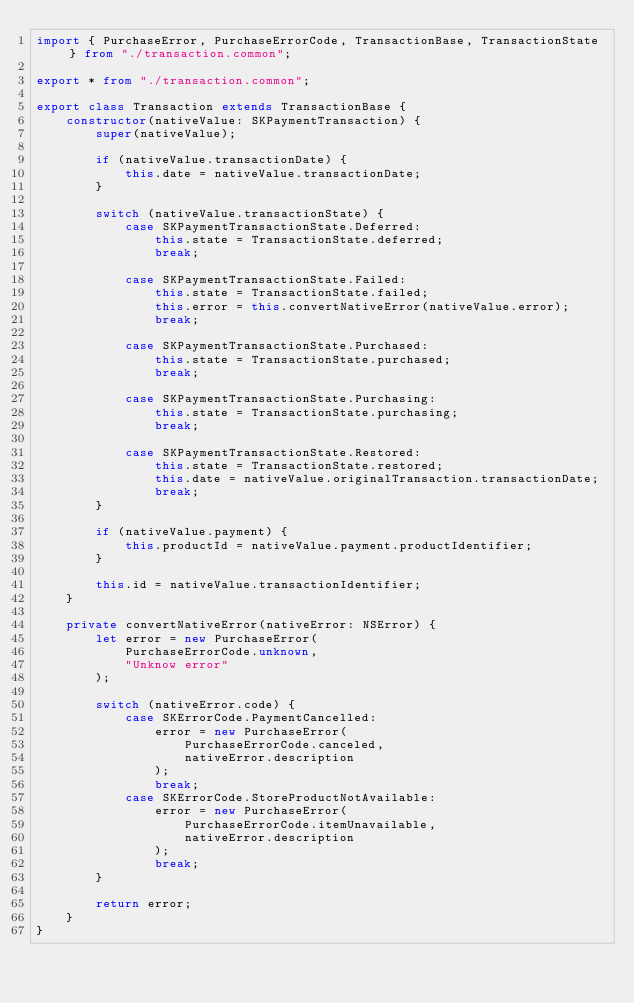<code> <loc_0><loc_0><loc_500><loc_500><_TypeScript_>import { PurchaseError, PurchaseErrorCode, TransactionBase, TransactionState } from "./transaction.common";

export * from "./transaction.common";

export class Transaction extends TransactionBase {
    constructor(nativeValue: SKPaymentTransaction) {
        super(nativeValue);

        if (nativeValue.transactionDate) {
            this.date = nativeValue.transactionDate;
        }

        switch (nativeValue.transactionState) {
            case SKPaymentTransactionState.Deferred:
                this.state = TransactionState.deferred;
                break;

            case SKPaymentTransactionState.Failed:
                this.state = TransactionState.failed;
                this.error = this.convertNativeError(nativeValue.error);
                break;

            case SKPaymentTransactionState.Purchased:
                this.state = TransactionState.purchased;
                break;

            case SKPaymentTransactionState.Purchasing:
                this.state = TransactionState.purchasing;
                break;

            case SKPaymentTransactionState.Restored:
                this.state = TransactionState.restored;
                this.date = nativeValue.originalTransaction.transactionDate;
                break;
        }

        if (nativeValue.payment) {
            this.productId = nativeValue.payment.productIdentifier;
        }

        this.id = nativeValue.transactionIdentifier;
    }

    private convertNativeError(nativeError: NSError) {
        let error = new PurchaseError(
            PurchaseErrorCode.unknown,
            "Unknow error"
        );

        switch (nativeError.code) {
            case SKErrorCode.PaymentCancelled:
                error = new PurchaseError(
                    PurchaseErrorCode.canceled,
                    nativeError.description
                );
                break;
            case SKErrorCode.StoreProductNotAvailable:
                error = new PurchaseError(
                    PurchaseErrorCode.itemUnavailable,
                    nativeError.description
                );
                break;
        }

        return error;
    }
}</code> 